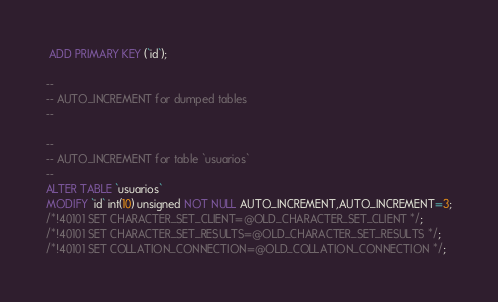Convert code to text. <code><loc_0><loc_0><loc_500><loc_500><_SQL_> ADD PRIMARY KEY (`id`);

--
-- AUTO_INCREMENT for dumped tables
--

--
-- AUTO_INCREMENT for table `usuarios`
--
ALTER TABLE `usuarios`
MODIFY `id` int(10) unsigned NOT NULL AUTO_INCREMENT,AUTO_INCREMENT=3;
/*!40101 SET CHARACTER_SET_CLIENT=@OLD_CHARACTER_SET_CLIENT */;
/*!40101 SET CHARACTER_SET_RESULTS=@OLD_CHARACTER_SET_RESULTS */;
/*!40101 SET COLLATION_CONNECTION=@OLD_COLLATION_CONNECTION */;
</code> 